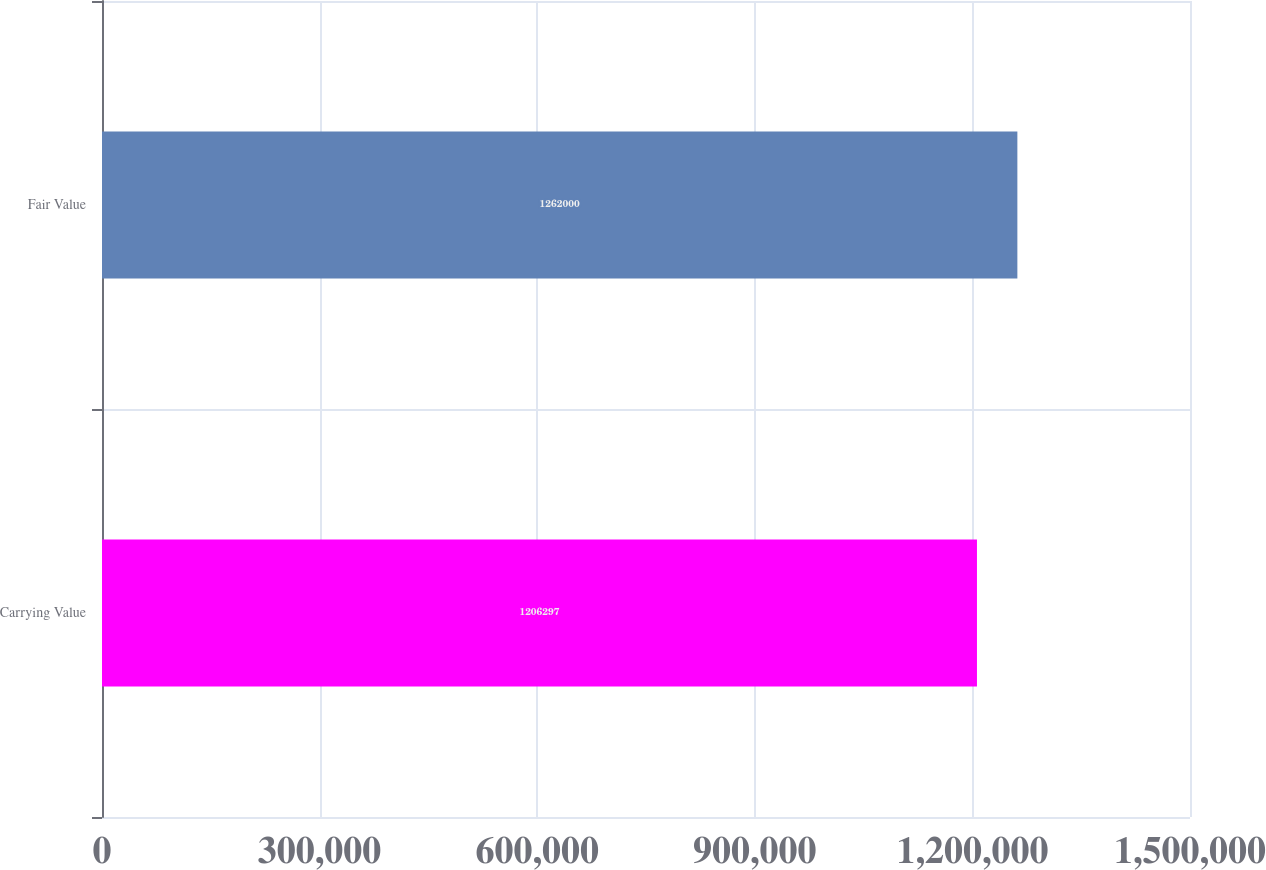Convert chart to OTSL. <chart><loc_0><loc_0><loc_500><loc_500><bar_chart><fcel>Carrying Value<fcel>Fair Value<nl><fcel>1.2063e+06<fcel>1.262e+06<nl></chart> 